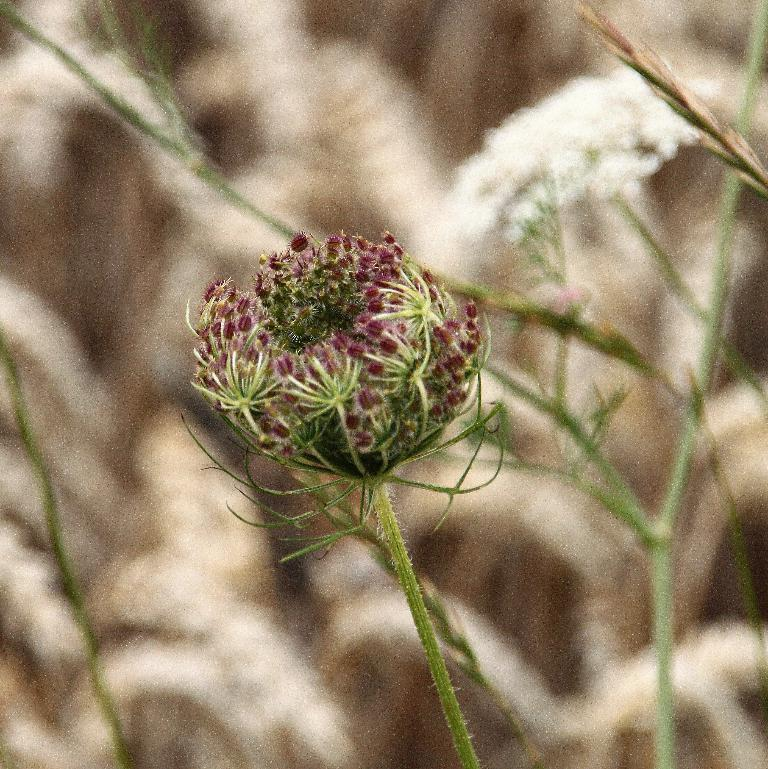What is the main subject in the center of the image? There is a flower in the center of the image. What can be seen in the background of the image? There are plants in the background of the image. What type of brake is visible on the flower in the image? There is no brake present in the image; it features a flower and plants. How many cards can be seen in the image? There are no cards present in the image. 